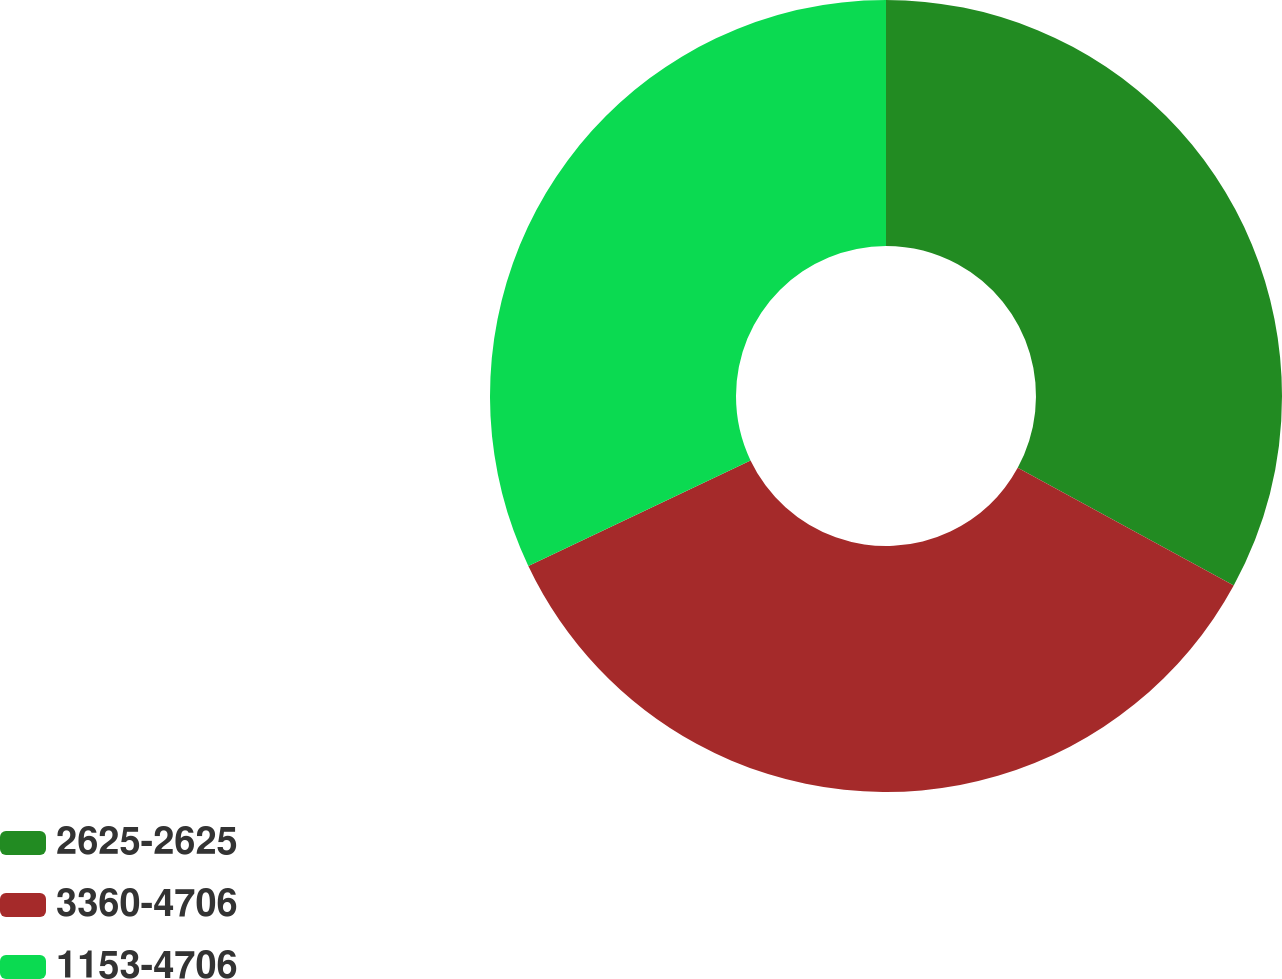Convert chart. <chart><loc_0><loc_0><loc_500><loc_500><pie_chart><fcel>2625-2625<fcel>3360-4706<fcel>1153-4706<nl><fcel>32.94%<fcel>35.0%<fcel>32.06%<nl></chart> 